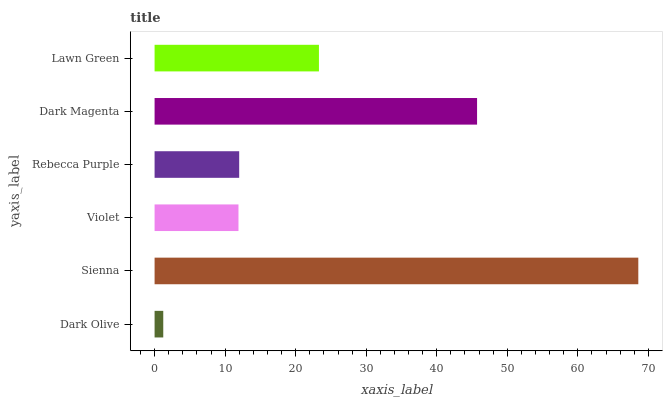Is Dark Olive the minimum?
Answer yes or no. Yes. Is Sienna the maximum?
Answer yes or no. Yes. Is Violet the minimum?
Answer yes or no. No. Is Violet the maximum?
Answer yes or no. No. Is Sienna greater than Violet?
Answer yes or no. Yes. Is Violet less than Sienna?
Answer yes or no. Yes. Is Violet greater than Sienna?
Answer yes or no. No. Is Sienna less than Violet?
Answer yes or no. No. Is Lawn Green the high median?
Answer yes or no. Yes. Is Rebecca Purple the low median?
Answer yes or no. Yes. Is Sienna the high median?
Answer yes or no. No. Is Dark Magenta the low median?
Answer yes or no. No. 